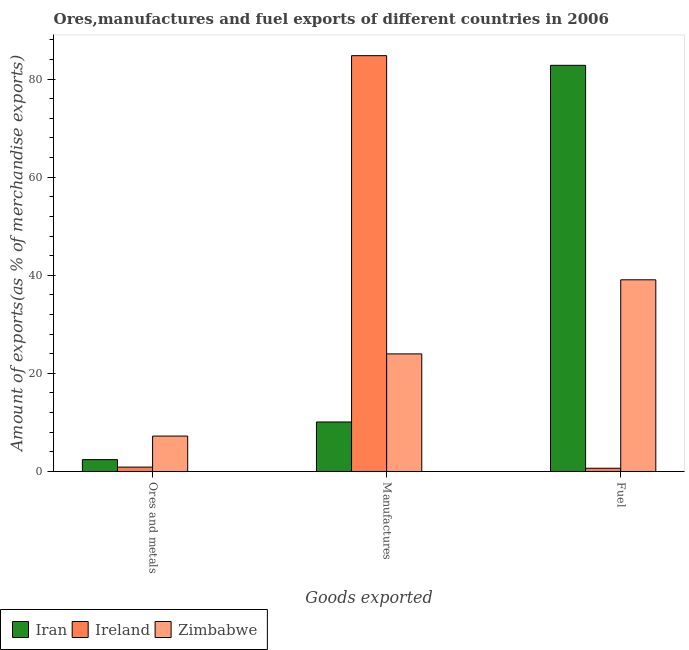How many bars are there on the 2nd tick from the left?
Keep it short and to the point. 3. What is the label of the 3rd group of bars from the left?
Make the answer very short. Fuel. What is the percentage of manufactures exports in Zimbabwe?
Provide a short and direct response. 23.97. Across all countries, what is the maximum percentage of manufactures exports?
Your answer should be compact. 84.76. Across all countries, what is the minimum percentage of fuel exports?
Your answer should be very brief. 0.66. In which country was the percentage of manufactures exports maximum?
Provide a short and direct response. Ireland. In which country was the percentage of manufactures exports minimum?
Your answer should be very brief. Iran. What is the total percentage of ores and metals exports in the graph?
Your answer should be very brief. 10.53. What is the difference between the percentage of manufactures exports in Zimbabwe and that in Iran?
Your answer should be compact. 13.88. What is the difference between the percentage of fuel exports in Ireland and the percentage of ores and metals exports in Zimbabwe?
Provide a succinct answer. -6.56. What is the average percentage of manufactures exports per country?
Provide a short and direct response. 39.61. What is the difference between the percentage of ores and metals exports and percentage of manufactures exports in Iran?
Give a very brief answer. -7.68. In how many countries, is the percentage of ores and metals exports greater than 80 %?
Give a very brief answer. 0. What is the ratio of the percentage of manufactures exports in Zimbabwe to that in Iran?
Give a very brief answer. 2.37. Is the percentage of manufactures exports in Zimbabwe less than that in Iran?
Your answer should be compact. No. What is the difference between the highest and the second highest percentage of manufactures exports?
Offer a very short reply. 60.79. What is the difference between the highest and the lowest percentage of manufactures exports?
Offer a very short reply. 74.67. In how many countries, is the percentage of manufactures exports greater than the average percentage of manufactures exports taken over all countries?
Make the answer very short. 1. Is the sum of the percentage of manufactures exports in Iran and Zimbabwe greater than the maximum percentage of fuel exports across all countries?
Offer a terse response. No. What does the 1st bar from the left in Manufactures represents?
Your response must be concise. Iran. What does the 2nd bar from the right in Manufactures represents?
Make the answer very short. Ireland. Is it the case that in every country, the sum of the percentage of ores and metals exports and percentage of manufactures exports is greater than the percentage of fuel exports?
Your response must be concise. No. How many countries are there in the graph?
Offer a terse response. 3. Are the values on the major ticks of Y-axis written in scientific E-notation?
Provide a short and direct response. No. Does the graph contain grids?
Make the answer very short. No. How are the legend labels stacked?
Offer a very short reply. Horizontal. What is the title of the graph?
Your response must be concise. Ores,manufactures and fuel exports of different countries in 2006. What is the label or title of the X-axis?
Ensure brevity in your answer.  Goods exported. What is the label or title of the Y-axis?
Ensure brevity in your answer.  Amount of exports(as % of merchandise exports). What is the Amount of exports(as % of merchandise exports) in Iran in Ores and metals?
Give a very brief answer. 2.42. What is the Amount of exports(as % of merchandise exports) in Ireland in Ores and metals?
Your answer should be very brief. 0.89. What is the Amount of exports(as % of merchandise exports) in Zimbabwe in Ores and metals?
Your answer should be very brief. 7.22. What is the Amount of exports(as % of merchandise exports) in Iran in Manufactures?
Offer a terse response. 10.09. What is the Amount of exports(as % of merchandise exports) of Ireland in Manufactures?
Your answer should be compact. 84.76. What is the Amount of exports(as % of merchandise exports) in Zimbabwe in Manufactures?
Make the answer very short. 23.97. What is the Amount of exports(as % of merchandise exports) of Iran in Fuel?
Offer a very short reply. 82.79. What is the Amount of exports(as % of merchandise exports) in Ireland in Fuel?
Your response must be concise. 0.66. What is the Amount of exports(as % of merchandise exports) in Zimbabwe in Fuel?
Ensure brevity in your answer.  39.07. Across all Goods exported, what is the maximum Amount of exports(as % of merchandise exports) in Iran?
Your answer should be compact. 82.79. Across all Goods exported, what is the maximum Amount of exports(as % of merchandise exports) in Ireland?
Keep it short and to the point. 84.76. Across all Goods exported, what is the maximum Amount of exports(as % of merchandise exports) in Zimbabwe?
Make the answer very short. 39.07. Across all Goods exported, what is the minimum Amount of exports(as % of merchandise exports) in Iran?
Keep it short and to the point. 2.42. Across all Goods exported, what is the minimum Amount of exports(as % of merchandise exports) of Ireland?
Your answer should be compact. 0.66. Across all Goods exported, what is the minimum Amount of exports(as % of merchandise exports) of Zimbabwe?
Provide a succinct answer. 7.22. What is the total Amount of exports(as % of merchandise exports) in Iran in the graph?
Keep it short and to the point. 95.3. What is the total Amount of exports(as % of merchandise exports) of Ireland in the graph?
Provide a short and direct response. 86.32. What is the total Amount of exports(as % of merchandise exports) of Zimbabwe in the graph?
Give a very brief answer. 70.26. What is the difference between the Amount of exports(as % of merchandise exports) of Iran in Ores and metals and that in Manufactures?
Your answer should be compact. -7.68. What is the difference between the Amount of exports(as % of merchandise exports) in Ireland in Ores and metals and that in Manufactures?
Your answer should be compact. -83.87. What is the difference between the Amount of exports(as % of merchandise exports) in Zimbabwe in Ores and metals and that in Manufactures?
Keep it short and to the point. -16.75. What is the difference between the Amount of exports(as % of merchandise exports) in Iran in Ores and metals and that in Fuel?
Provide a succinct answer. -80.38. What is the difference between the Amount of exports(as % of merchandise exports) of Ireland in Ores and metals and that in Fuel?
Your response must be concise. 0.23. What is the difference between the Amount of exports(as % of merchandise exports) of Zimbabwe in Ores and metals and that in Fuel?
Your answer should be very brief. -31.85. What is the difference between the Amount of exports(as % of merchandise exports) of Iran in Manufactures and that in Fuel?
Keep it short and to the point. -72.7. What is the difference between the Amount of exports(as % of merchandise exports) of Ireland in Manufactures and that in Fuel?
Make the answer very short. 84.1. What is the difference between the Amount of exports(as % of merchandise exports) of Zimbabwe in Manufactures and that in Fuel?
Offer a very short reply. -15.1. What is the difference between the Amount of exports(as % of merchandise exports) in Iran in Ores and metals and the Amount of exports(as % of merchandise exports) in Ireland in Manufactures?
Keep it short and to the point. -82.35. What is the difference between the Amount of exports(as % of merchandise exports) in Iran in Ores and metals and the Amount of exports(as % of merchandise exports) in Zimbabwe in Manufactures?
Your answer should be compact. -21.55. What is the difference between the Amount of exports(as % of merchandise exports) of Ireland in Ores and metals and the Amount of exports(as % of merchandise exports) of Zimbabwe in Manufactures?
Offer a terse response. -23.07. What is the difference between the Amount of exports(as % of merchandise exports) of Iran in Ores and metals and the Amount of exports(as % of merchandise exports) of Ireland in Fuel?
Offer a terse response. 1.76. What is the difference between the Amount of exports(as % of merchandise exports) of Iran in Ores and metals and the Amount of exports(as % of merchandise exports) of Zimbabwe in Fuel?
Ensure brevity in your answer.  -36.66. What is the difference between the Amount of exports(as % of merchandise exports) of Ireland in Ores and metals and the Amount of exports(as % of merchandise exports) of Zimbabwe in Fuel?
Ensure brevity in your answer.  -38.18. What is the difference between the Amount of exports(as % of merchandise exports) of Iran in Manufactures and the Amount of exports(as % of merchandise exports) of Ireland in Fuel?
Provide a short and direct response. 9.43. What is the difference between the Amount of exports(as % of merchandise exports) in Iran in Manufactures and the Amount of exports(as % of merchandise exports) in Zimbabwe in Fuel?
Ensure brevity in your answer.  -28.98. What is the difference between the Amount of exports(as % of merchandise exports) in Ireland in Manufactures and the Amount of exports(as % of merchandise exports) in Zimbabwe in Fuel?
Provide a short and direct response. 45.69. What is the average Amount of exports(as % of merchandise exports) in Iran per Goods exported?
Your answer should be compact. 31.77. What is the average Amount of exports(as % of merchandise exports) in Ireland per Goods exported?
Provide a short and direct response. 28.77. What is the average Amount of exports(as % of merchandise exports) of Zimbabwe per Goods exported?
Your answer should be compact. 23.42. What is the difference between the Amount of exports(as % of merchandise exports) of Iran and Amount of exports(as % of merchandise exports) of Ireland in Ores and metals?
Provide a short and direct response. 1.52. What is the difference between the Amount of exports(as % of merchandise exports) in Iran and Amount of exports(as % of merchandise exports) in Zimbabwe in Ores and metals?
Ensure brevity in your answer.  -4.8. What is the difference between the Amount of exports(as % of merchandise exports) of Ireland and Amount of exports(as % of merchandise exports) of Zimbabwe in Ores and metals?
Provide a short and direct response. -6.33. What is the difference between the Amount of exports(as % of merchandise exports) of Iran and Amount of exports(as % of merchandise exports) of Ireland in Manufactures?
Provide a succinct answer. -74.67. What is the difference between the Amount of exports(as % of merchandise exports) in Iran and Amount of exports(as % of merchandise exports) in Zimbabwe in Manufactures?
Offer a terse response. -13.88. What is the difference between the Amount of exports(as % of merchandise exports) of Ireland and Amount of exports(as % of merchandise exports) of Zimbabwe in Manufactures?
Provide a succinct answer. 60.79. What is the difference between the Amount of exports(as % of merchandise exports) of Iran and Amount of exports(as % of merchandise exports) of Ireland in Fuel?
Provide a succinct answer. 82.13. What is the difference between the Amount of exports(as % of merchandise exports) of Iran and Amount of exports(as % of merchandise exports) of Zimbabwe in Fuel?
Your answer should be very brief. 43.72. What is the difference between the Amount of exports(as % of merchandise exports) of Ireland and Amount of exports(as % of merchandise exports) of Zimbabwe in Fuel?
Make the answer very short. -38.41. What is the ratio of the Amount of exports(as % of merchandise exports) in Iran in Ores and metals to that in Manufactures?
Make the answer very short. 0.24. What is the ratio of the Amount of exports(as % of merchandise exports) in Ireland in Ores and metals to that in Manufactures?
Provide a short and direct response. 0.01. What is the ratio of the Amount of exports(as % of merchandise exports) in Zimbabwe in Ores and metals to that in Manufactures?
Give a very brief answer. 0.3. What is the ratio of the Amount of exports(as % of merchandise exports) in Iran in Ores and metals to that in Fuel?
Ensure brevity in your answer.  0.03. What is the ratio of the Amount of exports(as % of merchandise exports) in Ireland in Ores and metals to that in Fuel?
Your answer should be compact. 1.36. What is the ratio of the Amount of exports(as % of merchandise exports) of Zimbabwe in Ores and metals to that in Fuel?
Your response must be concise. 0.18. What is the ratio of the Amount of exports(as % of merchandise exports) of Iran in Manufactures to that in Fuel?
Offer a terse response. 0.12. What is the ratio of the Amount of exports(as % of merchandise exports) of Ireland in Manufactures to that in Fuel?
Make the answer very short. 128.45. What is the ratio of the Amount of exports(as % of merchandise exports) in Zimbabwe in Manufactures to that in Fuel?
Your response must be concise. 0.61. What is the difference between the highest and the second highest Amount of exports(as % of merchandise exports) in Iran?
Offer a very short reply. 72.7. What is the difference between the highest and the second highest Amount of exports(as % of merchandise exports) in Ireland?
Provide a short and direct response. 83.87. What is the difference between the highest and the second highest Amount of exports(as % of merchandise exports) of Zimbabwe?
Provide a short and direct response. 15.1. What is the difference between the highest and the lowest Amount of exports(as % of merchandise exports) in Iran?
Offer a terse response. 80.38. What is the difference between the highest and the lowest Amount of exports(as % of merchandise exports) of Ireland?
Your response must be concise. 84.1. What is the difference between the highest and the lowest Amount of exports(as % of merchandise exports) of Zimbabwe?
Give a very brief answer. 31.85. 